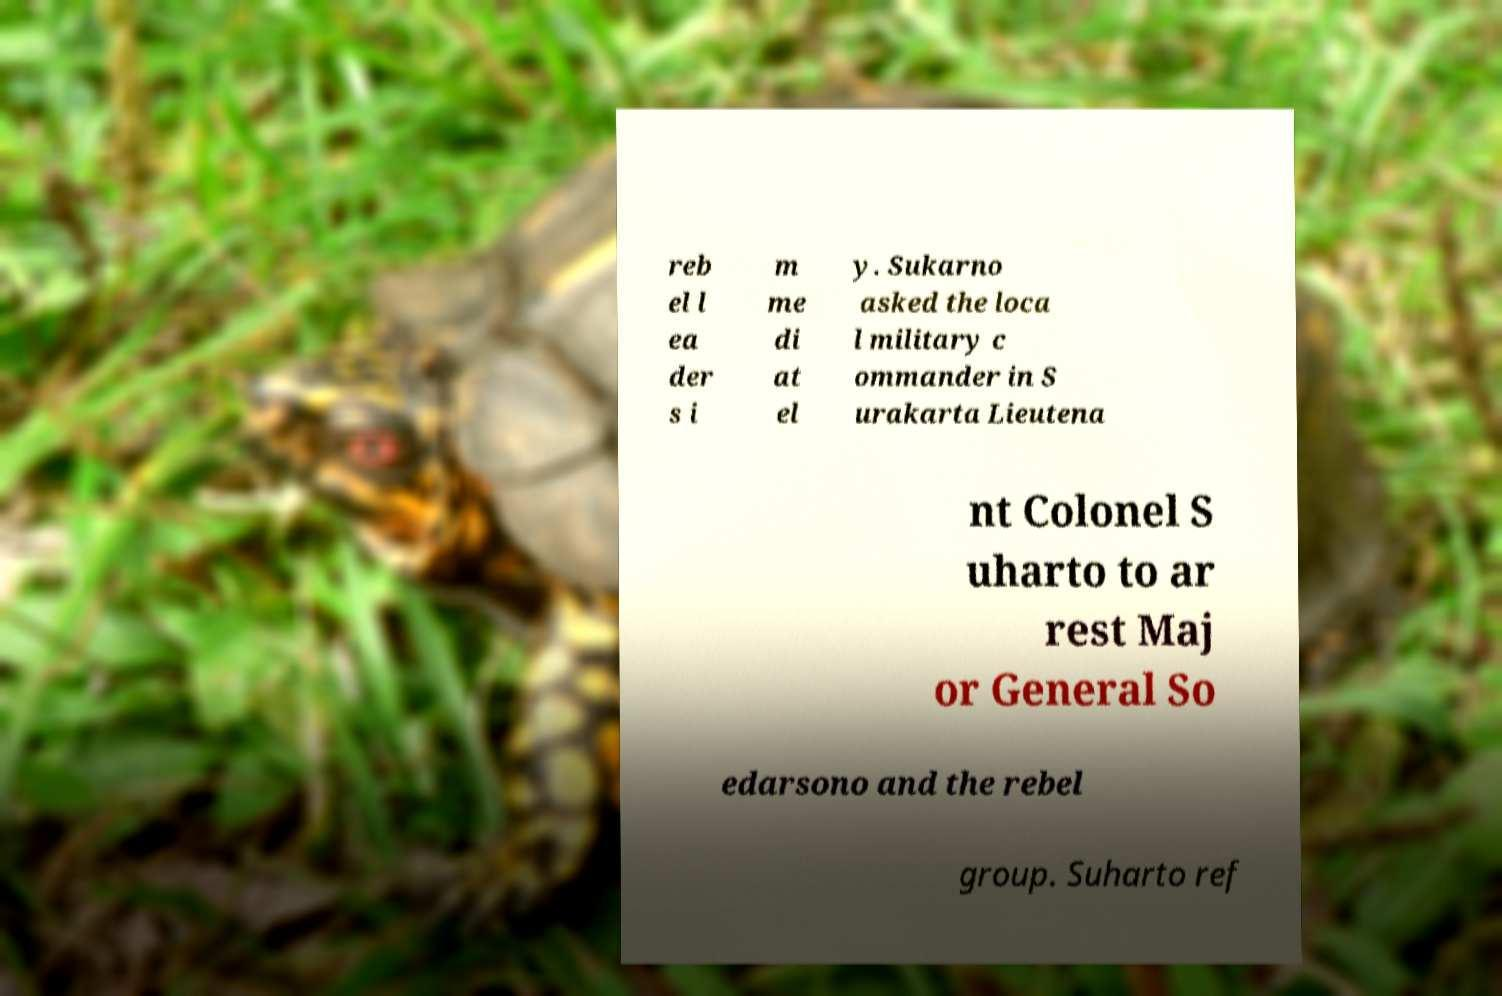Can you accurately transcribe the text from the provided image for me? reb el l ea der s i m me di at el y. Sukarno asked the loca l military c ommander in S urakarta Lieutena nt Colonel S uharto to ar rest Maj or General So edarsono and the rebel group. Suharto ref 